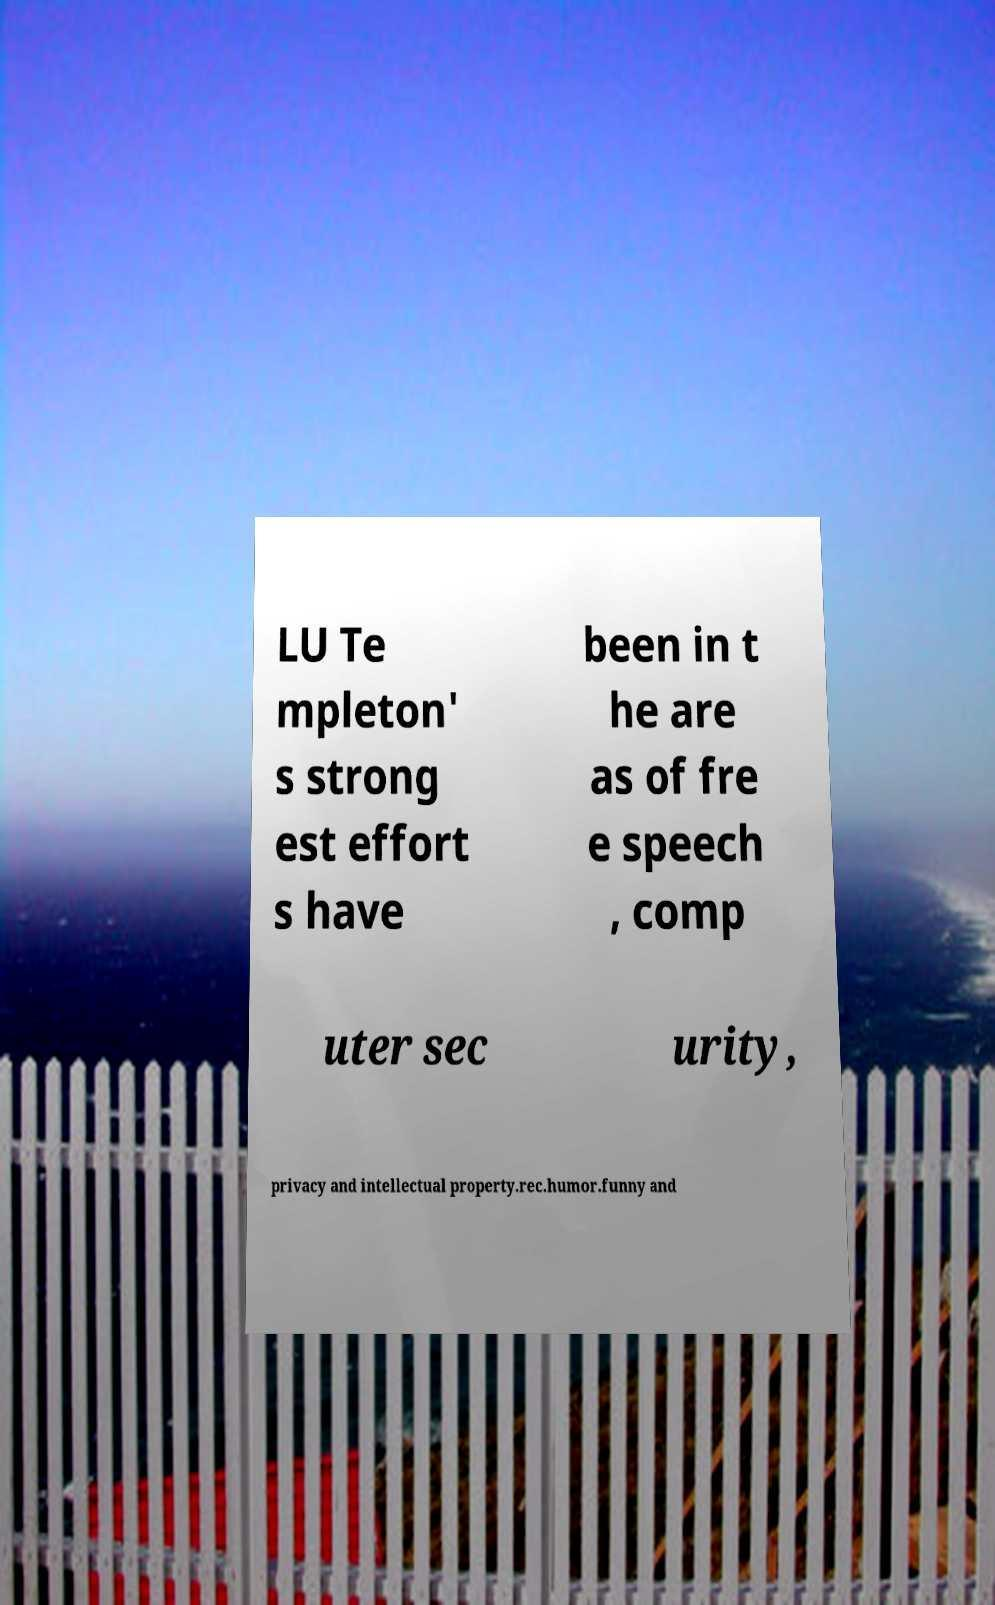Could you extract and type out the text from this image? LU Te mpleton' s strong est effort s have been in t he are as of fre e speech , comp uter sec urity, privacy and intellectual property.rec.humor.funny and 